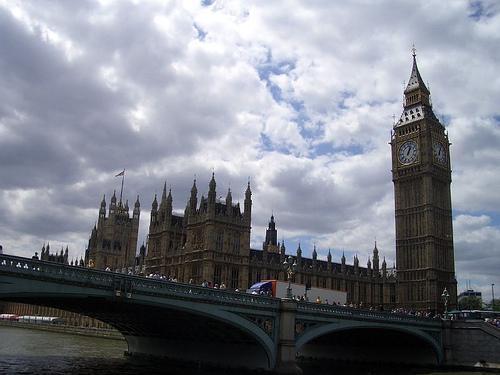How many clock faces are there?
Give a very brief answer. 2. How many children are on bicycles in this image?
Give a very brief answer. 0. 